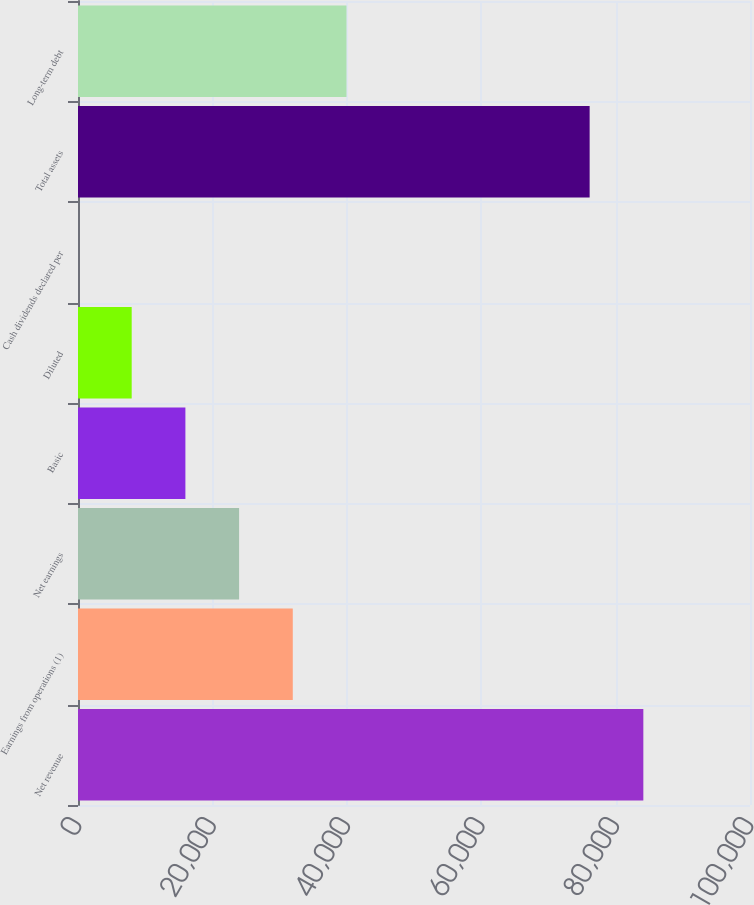Convert chart. <chart><loc_0><loc_0><loc_500><loc_500><bar_chart><fcel>Net revenue<fcel>Earnings from operations (1)<fcel>Net earnings<fcel>Basic<fcel>Diluted<fcel>Cash dividends declared per<fcel>Total assets<fcel>Long-term debt<nl><fcel>84128.5<fcel>31962.2<fcel>23971.7<fcel>15981.3<fcel>7990.79<fcel>0.32<fcel>76138<fcel>39952.7<nl></chart> 